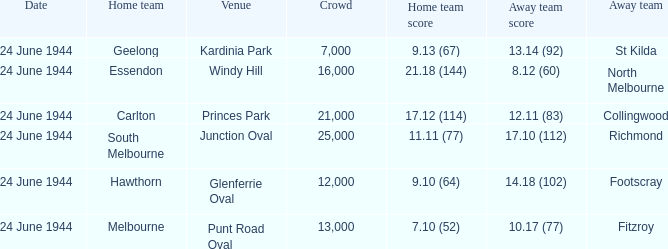Help me parse the entirety of this table. {'header': ['Date', 'Home team', 'Venue', 'Crowd', 'Home team score', 'Away team score', 'Away team'], 'rows': [['24 June 1944', 'Geelong', 'Kardinia Park', '7,000', '9.13 (67)', '13.14 (92)', 'St Kilda'], ['24 June 1944', 'Essendon', 'Windy Hill', '16,000', '21.18 (144)', '8.12 (60)', 'North Melbourne'], ['24 June 1944', 'Carlton', 'Princes Park', '21,000', '17.12 (114)', '12.11 (83)', 'Collingwood'], ['24 June 1944', 'South Melbourne', 'Junction Oval', '25,000', '11.11 (77)', '17.10 (112)', 'Richmond'], ['24 June 1944', 'Hawthorn', 'Glenferrie Oval', '12,000', '9.10 (64)', '14.18 (102)', 'Footscray'], ['24 June 1944', 'Melbourne', 'Punt Road Oval', '13,000', '7.10 (52)', '10.17 (77)', 'Fitzroy']]} When the Crowd was larger than 25,000. what was the Home Team score? None. 